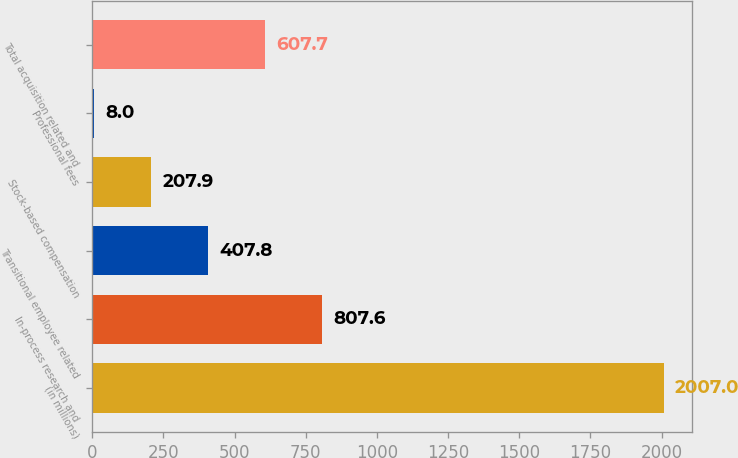Convert chart to OTSL. <chart><loc_0><loc_0><loc_500><loc_500><bar_chart><fcel>(in millions)<fcel>In-process research and<fcel>Transitional employee related<fcel>Stock-based compensation<fcel>Professional fees<fcel>Total acquisition related and<nl><fcel>2007<fcel>807.6<fcel>407.8<fcel>207.9<fcel>8<fcel>607.7<nl></chart> 